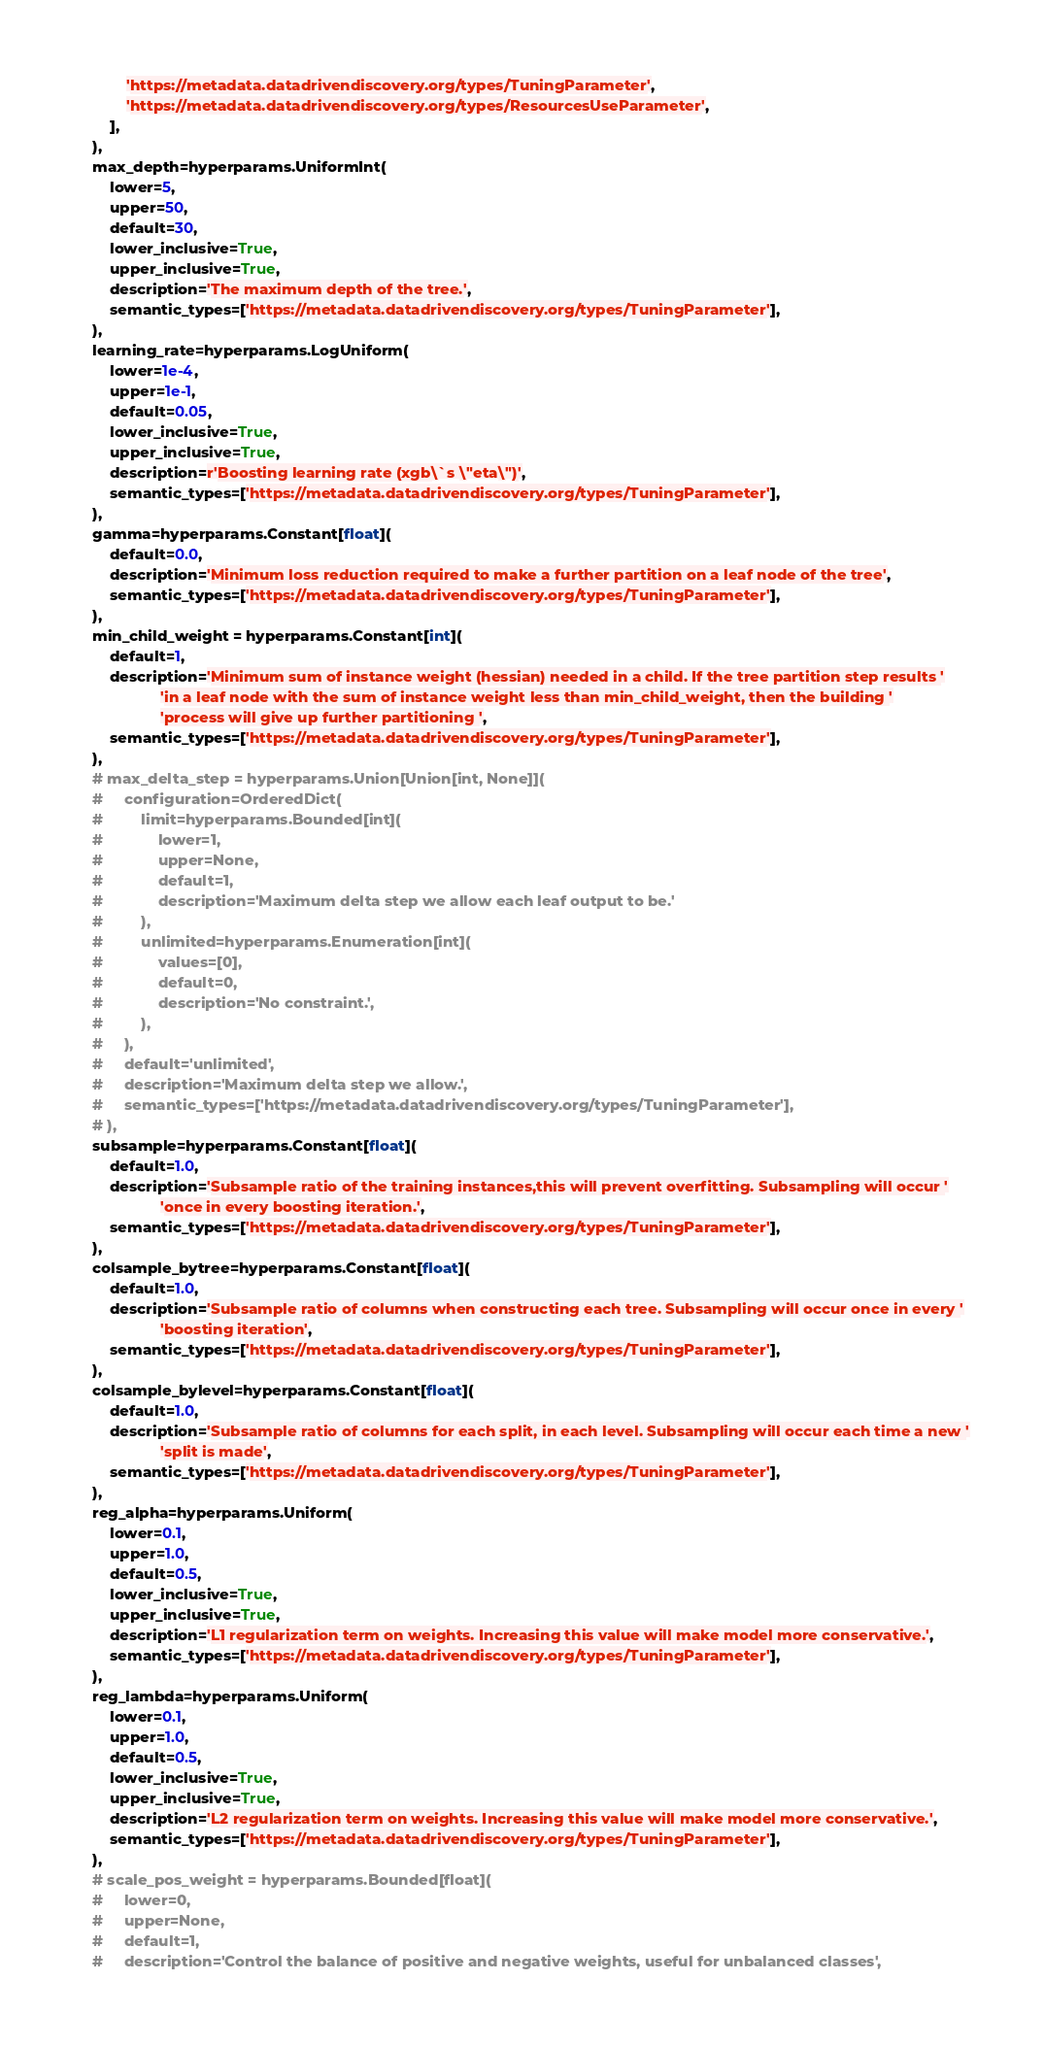<code> <loc_0><loc_0><loc_500><loc_500><_Python_>            'https://metadata.datadrivendiscovery.org/types/TuningParameter',
            'https://metadata.datadrivendiscovery.org/types/ResourcesUseParameter',
        ],
    ),
    max_depth=hyperparams.UniformInt(
        lower=5,
        upper=50,
        default=30,
        lower_inclusive=True,
        upper_inclusive=True,
        description='The maximum depth of the tree.',
        semantic_types=['https://metadata.datadrivendiscovery.org/types/TuningParameter'],
    ),
    learning_rate=hyperparams.LogUniform(
        lower=1e-4,
        upper=1e-1,
        default=0.05,
        lower_inclusive=True,
        upper_inclusive=True,
        description=r'Boosting learning rate (xgb\`s \"eta\")',
        semantic_types=['https://metadata.datadrivendiscovery.org/types/TuningParameter'],
    ),
    gamma=hyperparams.Constant[float](
        default=0.0,
        description='Minimum loss reduction required to make a further partition on a leaf node of the tree',
        semantic_types=['https://metadata.datadrivendiscovery.org/types/TuningParameter'],
    ),
    min_child_weight = hyperparams.Constant[int](
        default=1,
        description='Minimum sum of instance weight (hessian) needed in a child. If the tree partition step results '
                    'in a leaf node with the sum of instance weight less than min_child_weight, then the building '
                    'process will give up further partitioning ',
        semantic_types=['https://metadata.datadrivendiscovery.org/types/TuningParameter'],
    ),
    # max_delta_step = hyperparams.Union[Union[int, None]](
    #     configuration=OrderedDict(
    #         limit=hyperparams.Bounded[int](
    #             lower=1,
    #             upper=None,
    #             default=1,
    #             description='Maximum delta step we allow each leaf output to be.'
    #         ),
    #         unlimited=hyperparams.Enumeration[int](
    #             values=[0],
    #             default=0,
    #             description='No constraint.',
    #         ),
    #     ),
    #     default='unlimited',
    #     description='Maximum delta step we allow.',
    #     semantic_types=['https://metadata.datadrivendiscovery.org/types/TuningParameter'],
    # ),
    subsample=hyperparams.Constant[float](
        default=1.0,
        description='Subsample ratio of the training instances,this will prevent overfitting. Subsampling will occur '
                    'once in every boosting iteration.',
        semantic_types=['https://metadata.datadrivendiscovery.org/types/TuningParameter'],
    ),
    colsample_bytree=hyperparams.Constant[float](
        default=1.0,
        description='Subsample ratio of columns when constructing each tree. Subsampling will occur once in every '
                    'boosting iteration',
        semantic_types=['https://metadata.datadrivendiscovery.org/types/TuningParameter'],
    ),
    colsample_bylevel=hyperparams.Constant[float](
        default=1.0,
        description='Subsample ratio of columns for each split, in each level. Subsampling will occur each time a new '
                    'split is made',
        semantic_types=['https://metadata.datadrivendiscovery.org/types/TuningParameter'],
    ),
    reg_alpha=hyperparams.Uniform(
        lower=0.1,
        upper=1.0,
        default=0.5,
        lower_inclusive=True,
        upper_inclusive=True,
        description='L1 regularization term on weights. Increasing this value will make model more conservative.',
        semantic_types=['https://metadata.datadrivendiscovery.org/types/TuningParameter'],
    ),
    reg_lambda=hyperparams.Uniform(
        lower=0.1,
        upper=1.0,
        default=0.5,
        lower_inclusive=True,
        upper_inclusive=True,
        description='L2 regularization term on weights. Increasing this value will make model more conservative.',
        semantic_types=['https://metadata.datadrivendiscovery.org/types/TuningParameter'],
    ),
    # scale_pos_weight = hyperparams.Bounded[float](
    #     lower=0,
    #     upper=None,
    #     default=1,
    #     description='Control the balance of positive and negative weights, useful for unbalanced classes',</code> 